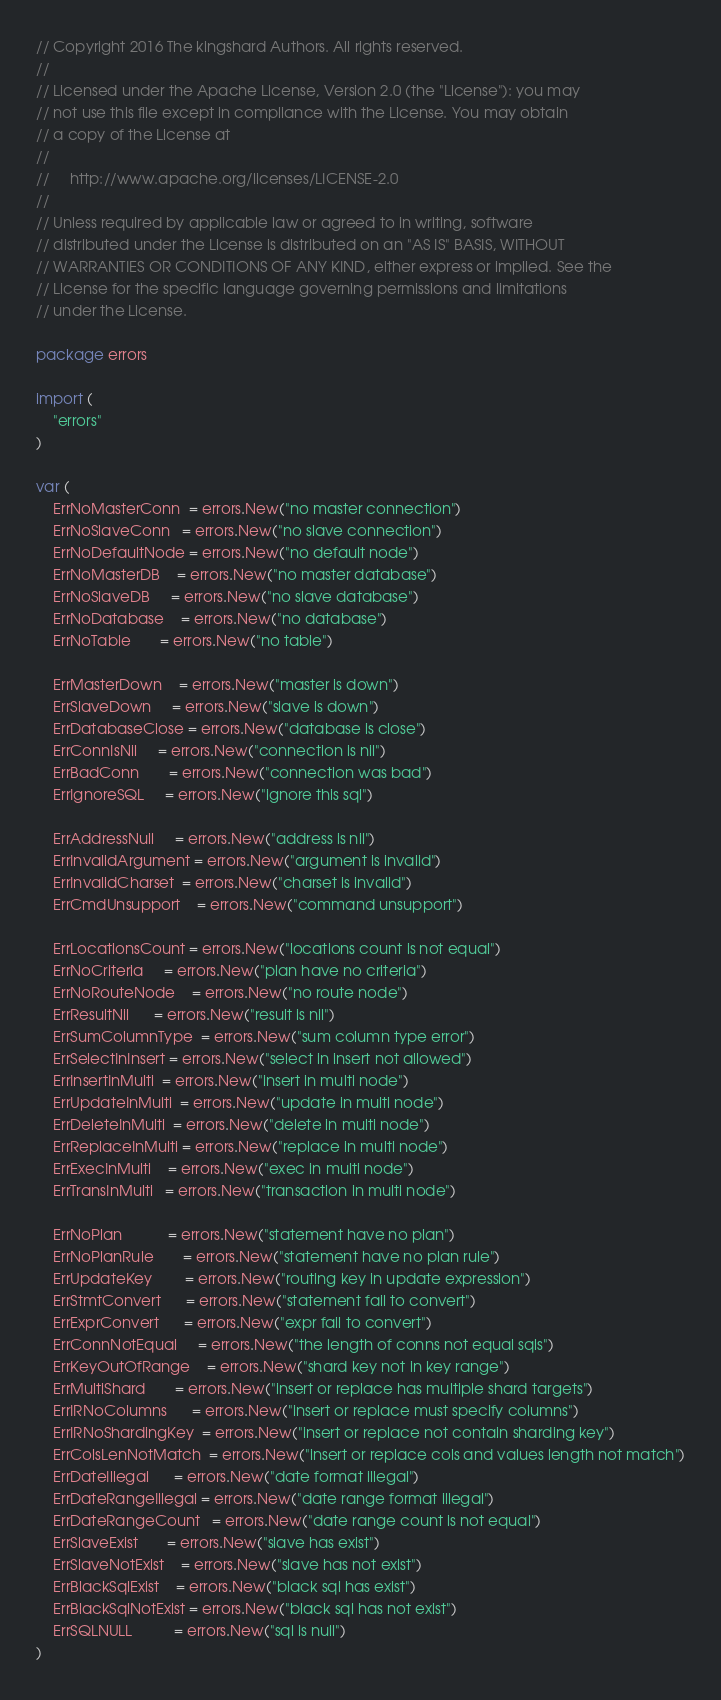<code> <loc_0><loc_0><loc_500><loc_500><_Go_>// Copyright 2016 The kingshard Authors. All rights reserved.
//
// Licensed under the Apache License, Version 2.0 (the "License"): you may
// not use this file except in compliance with the License. You may obtain
// a copy of the License at
//
//     http://www.apache.org/licenses/LICENSE-2.0
//
// Unless required by applicable law or agreed to in writing, software
// distributed under the License is distributed on an "AS IS" BASIS, WITHOUT
// WARRANTIES OR CONDITIONS OF ANY KIND, either express or implied. See the
// License for the specific language governing permissions and limitations
// under the License.

package errors

import (
	"errors"
)

var (
	ErrNoMasterConn  = errors.New("no master connection")
	ErrNoSlaveConn   = errors.New("no slave connection")
	ErrNoDefaultNode = errors.New("no default node")
	ErrNoMasterDB    = errors.New("no master database")
	ErrNoSlaveDB     = errors.New("no slave database")
	ErrNoDatabase    = errors.New("no database")
	ErrNoTable       = errors.New("no table")

	ErrMasterDown    = errors.New("master is down")
	ErrSlaveDown     = errors.New("slave is down")
	ErrDatabaseClose = errors.New("database is close")
	ErrConnIsNil     = errors.New("connection is nil")
	ErrBadConn       = errors.New("connection was bad")
	ErrIgnoreSQL     = errors.New("ignore this sql")

	ErrAddressNull     = errors.New("address is nil")
	ErrInvalidArgument = errors.New("argument is invalid")
	ErrInvalidCharset  = errors.New("charset is invalid")
	ErrCmdUnsupport    = errors.New("command unsupport")

	ErrLocationsCount = errors.New("locations count is not equal")
	ErrNoCriteria     = errors.New("plan have no criteria")
	ErrNoRouteNode    = errors.New("no route node")
	ErrResultNil      = errors.New("result is nil")
	ErrSumColumnType  = errors.New("sum column type error")
	ErrSelectInInsert = errors.New("select in insert not allowed")
	ErrInsertInMulti  = errors.New("insert in multi node")
	ErrUpdateInMulti  = errors.New("update in multi node")
	ErrDeleteInMulti  = errors.New("delete in multi node")
	ErrReplaceInMulti = errors.New("replace in multi node")
	ErrExecInMulti    = errors.New("exec in multi node")
	ErrTransInMulti   = errors.New("transaction in multi node")

	ErrNoPlan           = errors.New("statement have no plan")
	ErrNoPlanRule       = errors.New("statement have no plan rule")
	ErrUpdateKey        = errors.New("routing key in update expression")
	ErrStmtConvert      = errors.New("statement fail to convert")
	ErrExprConvert      = errors.New("expr fail to convert")
	ErrConnNotEqual     = errors.New("the length of conns not equal sqls")
	ErrKeyOutOfRange    = errors.New("shard key not in key range")
	ErrMultiShard       = errors.New("insert or replace has multiple shard targets")
	ErrIRNoColumns      = errors.New("insert or replace must specify columns")
	ErrIRNoShardingKey  = errors.New("insert or replace not contain sharding key")
	ErrColsLenNotMatch  = errors.New("insert or replace cols and values length not match")
	ErrDateIllegal      = errors.New("date format illegal")
	ErrDateRangeIllegal = errors.New("date range format illegal")
	ErrDateRangeCount   = errors.New("date range count is not equal")
	ErrSlaveExist       = errors.New("slave has exist")
	ErrSlaveNotExist    = errors.New("slave has not exist")
	ErrBlackSqlExist    = errors.New("black sql has exist")
	ErrBlackSqlNotExist = errors.New("black sql has not exist")
	ErrSQLNULL          = errors.New("sql is null")
)
</code> 